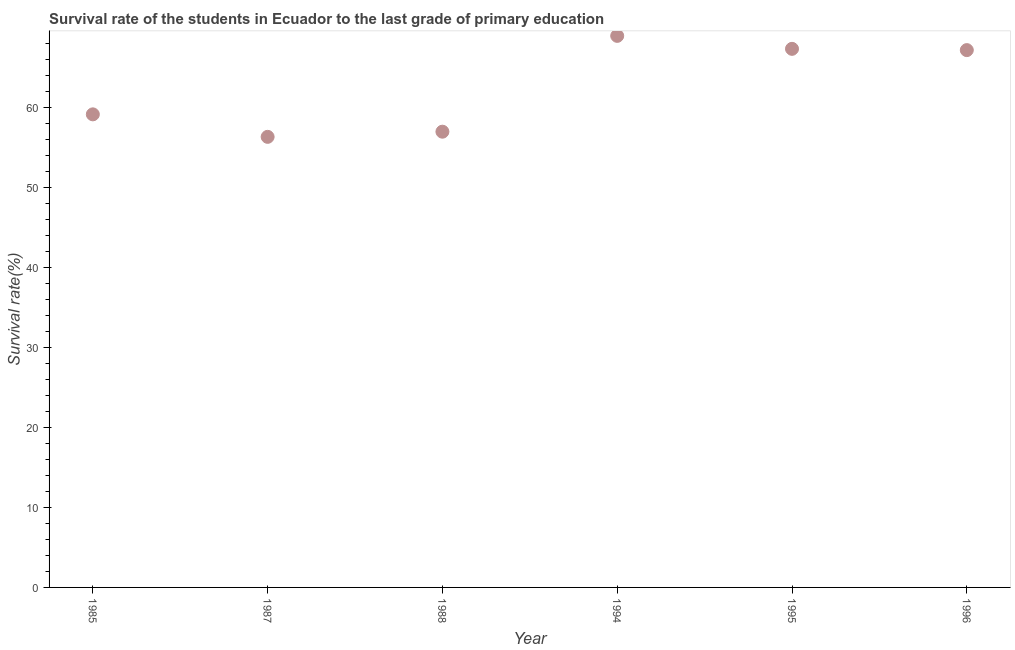What is the survival rate in primary education in 1996?
Give a very brief answer. 67.2. Across all years, what is the maximum survival rate in primary education?
Provide a succinct answer. 68.98. Across all years, what is the minimum survival rate in primary education?
Your answer should be very brief. 56.35. What is the sum of the survival rate in primary education?
Ensure brevity in your answer.  376.07. What is the difference between the survival rate in primary education in 1994 and 1996?
Give a very brief answer. 1.78. What is the average survival rate in primary education per year?
Provide a short and direct response. 62.68. What is the median survival rate in primary education?
Provide a short and direct response. 63.19. In how many years, is the survival rate in primary education greater than 12 %?
Ensure brevity in your answer.  6. What is the ratio of the survival rate in primary education in 1985 to that in 1996?
Ensure brevity in your answer.  0.88. What is the difference between the highest and the second highest survival rate in primary education?
Provide a succinct answer. 1.62. Is the sum of the survival rate in primary education in 1985 and 1988 greater than the maximum survival rate in primary education across all years?
Ensure brevity in your answer.  Yes. What is the difference between the highest and the lowest survival rate in primary education?
Provide a short and direct response. 12.63. In how many years, is the survival rate in primary education greater than the average survival rate in primary education taken over all years?
Make the answer very short. 3. How many dotlines are there?
Ensure brevity in your answer.  1. What is the difference between two consecutive major ticks on the Y-axis?
Ensure brevity in your answer.  10. What is the title of the graph?
Ensure brevity in your answer.  Survival rate of the students in Ecuador to the last grade of primary education. What is the label or title of the Y-axis?
Keep it short and to the point. Survival rate(%). What is the Survival rate(%) in 1985?
Your answer should be very brief. 59.17. What is the Survival rate(%) in 1987?
Provide a short and direct response. 56.35. What is the Survival rate(%) in 1988?
Provide a short and direct response. 57. What is the Survival rate(%) in 1994?
Ensure brevity in your answer.  68.98. What is the Survival rate(%) in 1995?
Make the answer very short. 67.36. What is the Survival rate(%) in 1996?
Provide a short and direct response. 67.2. What is the difference between the Survival rate(%) in 1985 and 1987?
Keep it short and to the point. 2.81. What is the difference between the Survival rate(%) in 1985 and 1988?
Ensure brevity in your answer.  2.17. What is the difference between the Survival rate(%) in 1985 and 1994?
Make the answer very short. -9.82. What is the difference between the Survival rate(%) in 1985 and 1995?
Offer a terse response. -8.19. What is the difference between the Survival rate(%) in 1985 and 1996?
Offer a very short reply. -8.03. What is the difference between the Survival rate(%) in 1987 and 1988?
Make the answer very short. -0.64. What is the difference between the Survival rate(%) in 1987 and 1994?
Offer a terse response. -12.63. What is the difference between the Survival rate(%) in 1987 and 1995?
Your answer should be compact. -11.01. What is the difference between the Survival rate(%) in 1987 and 1996?
Provide a succinct answer. -10.85. What is the difference between the Survival rate(%) in 1988 and 1994?
Provide a succinct answer. -11.98. What is the difference between the Survival rate(%) in 1988 and 1995?
Your answer should be very brief. -10.36. What is the difference between the Survival rate(%) in 1988 and 1996?
Give a very brief answer. -10.2. What is the difference between the Survival rate(%) in 1994 and 1995?
Provide a short and direct response. 1.62. What is the difference between the Survival rate(%) in 1994 and 1996?
Ensure brevity in your answer.  1.78. What is the difference between the Survival rate(%) in 1995 and 1996?
Ensure brevity in your answer.  0.16. What is the ratio of the Survival rate(%) in 1985 to that in 1987?
Offer a very short reply. 1.05. What is the ratio of the Survival rate(%) in 1985 to that in 1988?
Provide a succinct answer. 1.04. What is the ratio of the Survival rate(%) in 1985 to that in 1994?
Ensure brevity in your answer.  0.86. What is the ratio of the Survival rate(%) in 1985 to that in 1995?
Give a very brief answer. 0.88. What is the ratio of the Survival rate(%) in 1985 to that in 1996?
Keep it short and to the point. 0.88. What is the ratio of the Survival rate(%) in 1987 to that in 1994?
Give a very brief answer. 0.82. What is the ratio of the Survival rate(%) in 1987 to that in 1995?
Your response must be concise. 0.84. What is the ratio of the Survival rate(%) in 1987 to that in 1996?
Provide a succinct answer. 0.84. What is the ratio of the Survival rate(%) in 1988 to that in 1994?
Make the answer very short. 0.83. What is the ratio of the Survival rate(%) in 1988 to that in 1995?
Your answer should be very brief. 0.85. What is the ratio of the Survival rate(%) in 1988 to that in 1996?
Give a very brief answer. 0.85. What is the ratio of the Survival rate(%) in 1994 to that in 1996?
Your answer should be very brief. 1.03. What is the ratio of the Survival rate(%) in 1995 to that in 1996?
Your answer should be very brief. 1. 